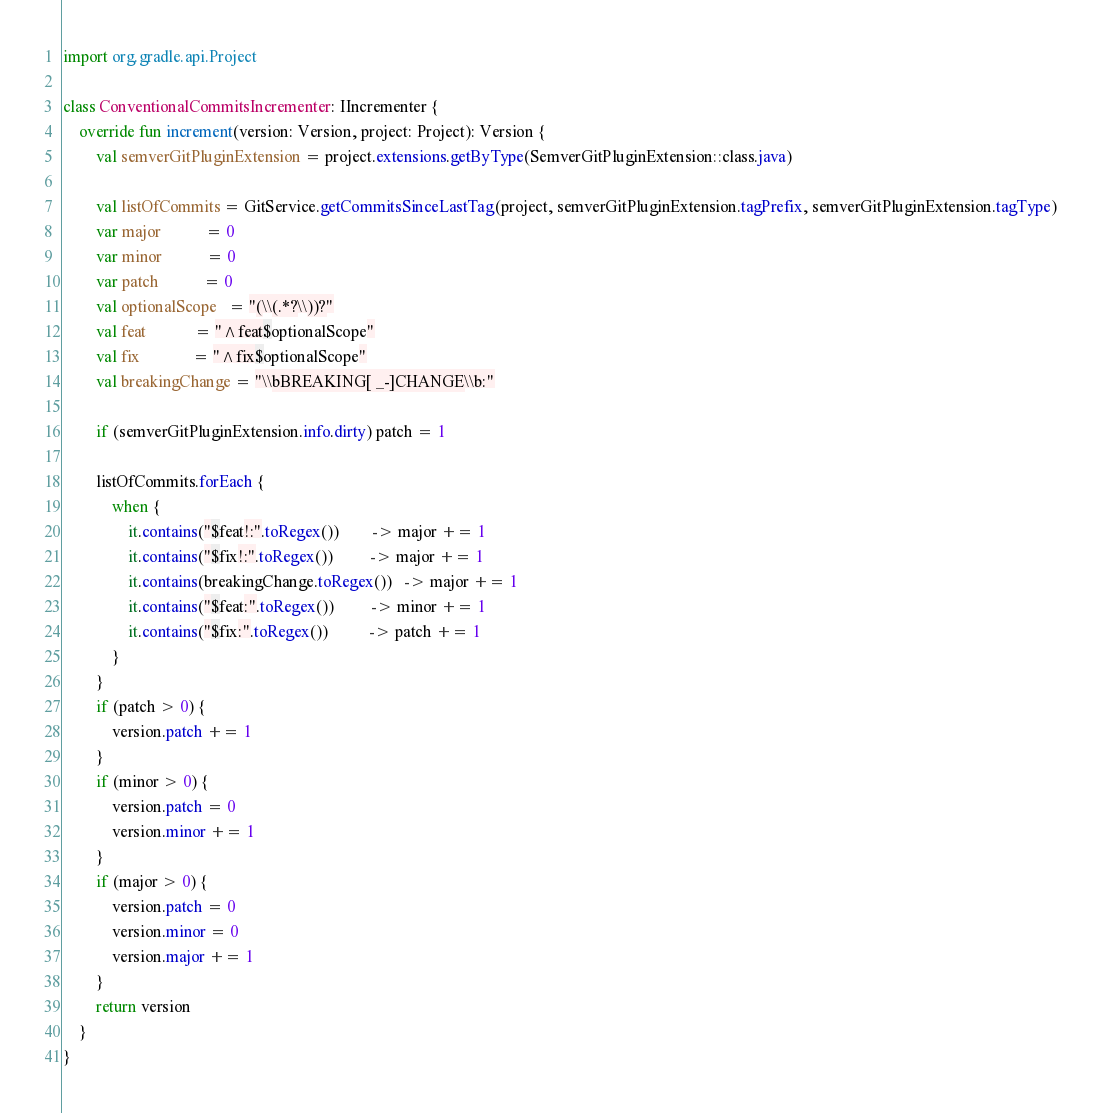Convert code to text. <code><loc_0><loc_0><loc_500><loc_500><_Kotlin_>import org.gradle.api.Project

class ConventionalCommitsIncrementer: IIncrementer {
    override fun increment(version: Version, project: Project): Version {
        val semverGitPluginExtension = project.extensions.getByType(SemverGitPluginExtension::class.java)

        val listOfCommits = GitService.getCommitsSinceLastTag(project, semverGitPluginExtension.tagPrefix, semverGitPluginExtension.tagType)
        var major           = 0
        var minor           = 0
        var patch           = 0
        val optionalScope   = "(\\(.*?\\))?"
        val feat            = "^feat$optionalScope"
        val fix             = "^fix$optionalScope"
        val breakingChange = "\\bBREAKING[ _-]CHANGE\\b:"

        if (semverGitPluginExtension.info.dirty) patch = 1

        listOfCommits.forEach {
            when {
                it.contains("$feat!:".toRegex())        -> major += 1
                it.contains("$fix!:".toRegex())         -> major += 1
                it.contains(breakingChange.toRegex())   -> major += 1
                it.contains("$feat:".toRegex())         -> minor += 1
                it.contains("$fix:".toRegex())          -> patch += 1
            }
        }
        if (patch > 0) {
            version.patch += 1
        }
        if (minor > 0) {
            version.patch = 0
            version.minor += 1
        }
        if (major > 0) {
            version.patch = 0
            version.minor = 0
            version.major += 1
        }
        return version
    }
}
</code> 